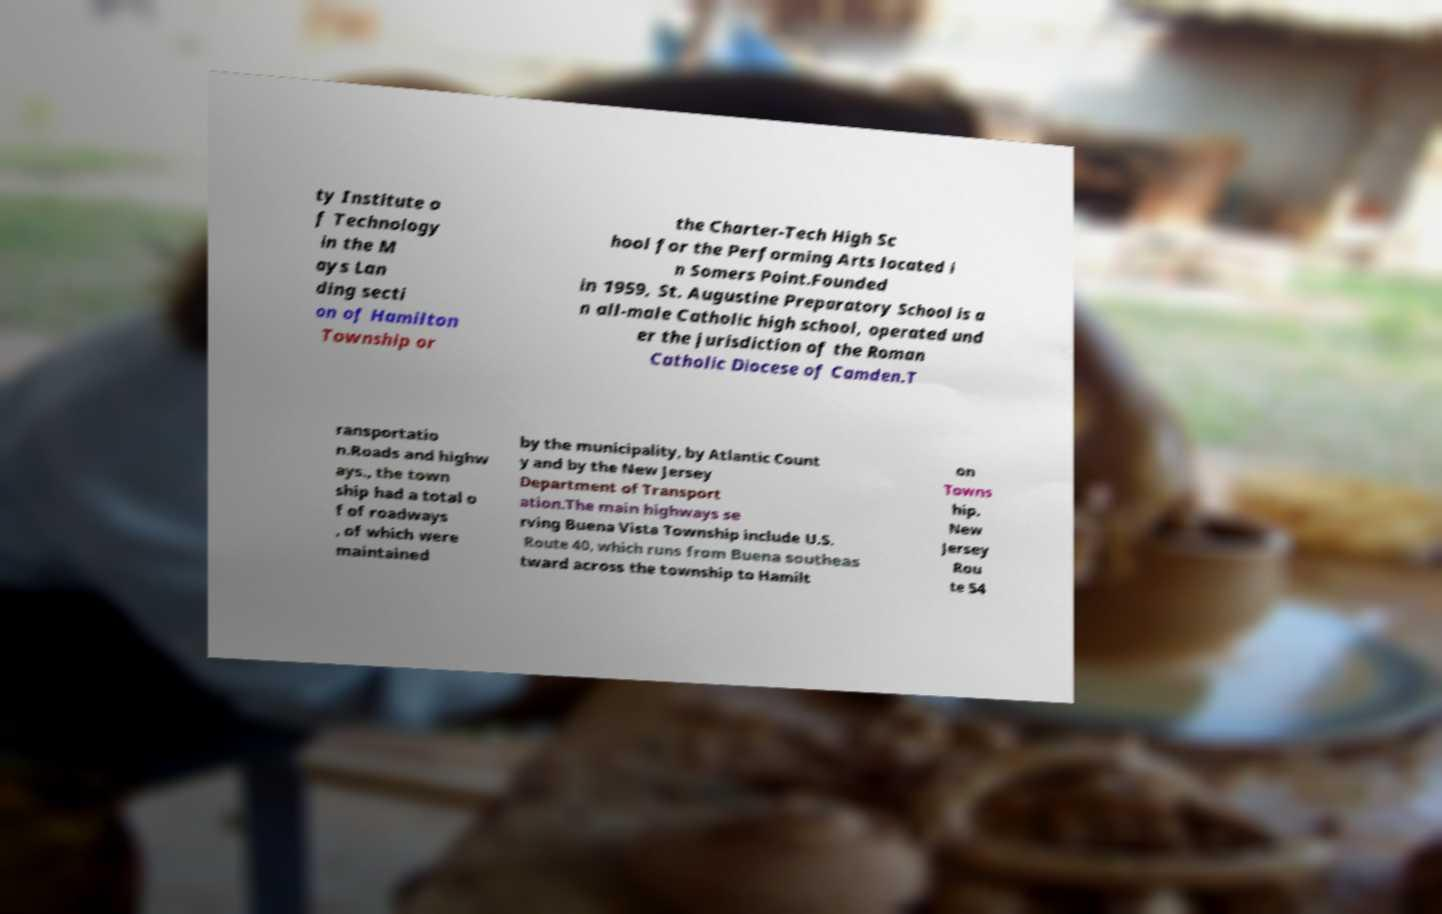Please identify and transcribe the text found in this image. ty Institute o f Technology in the M ays Lan ding secti on of Hamilton Township or the Charter-Tech High Sc hool for the Performing Arts located i n Somers Point.Founded in 1959, St. Augustine Preparatory School is a n all-male Catholic high school, operated und er the jurisdiction of the Roman Catholic Diocese of Camden.T ransportatio n.Roads and highw ays., the town ship had a total o f of roadways , of which were maintained by the municipality, by Atlantic Count y and by the New Jersey Department of Transport ation.The main highways se rving Buena Vista Township include U.S. Route 40, which runs from Buena southeas tward across the township to Hamilt on Towns hip. New Jersey Rou te 54 